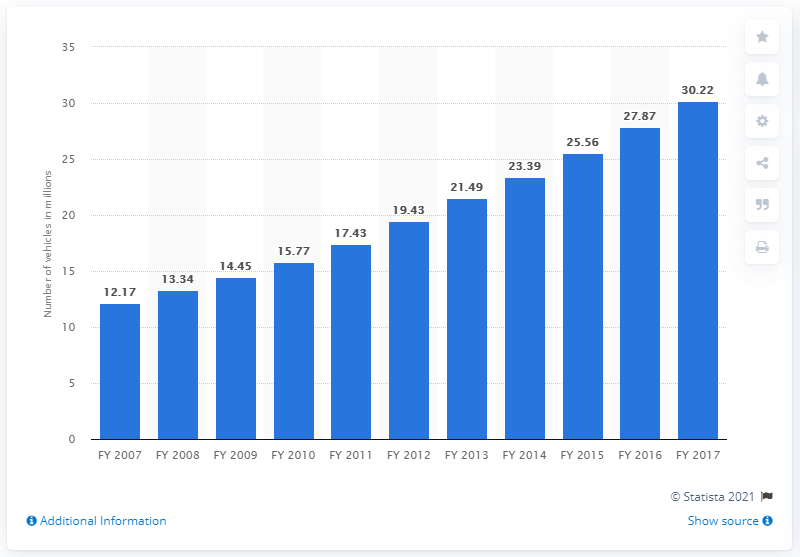Specify some key components in this picture. At the end of the fiscal year 2017, there were 30,220 registered vehicles in Maharashtra. 